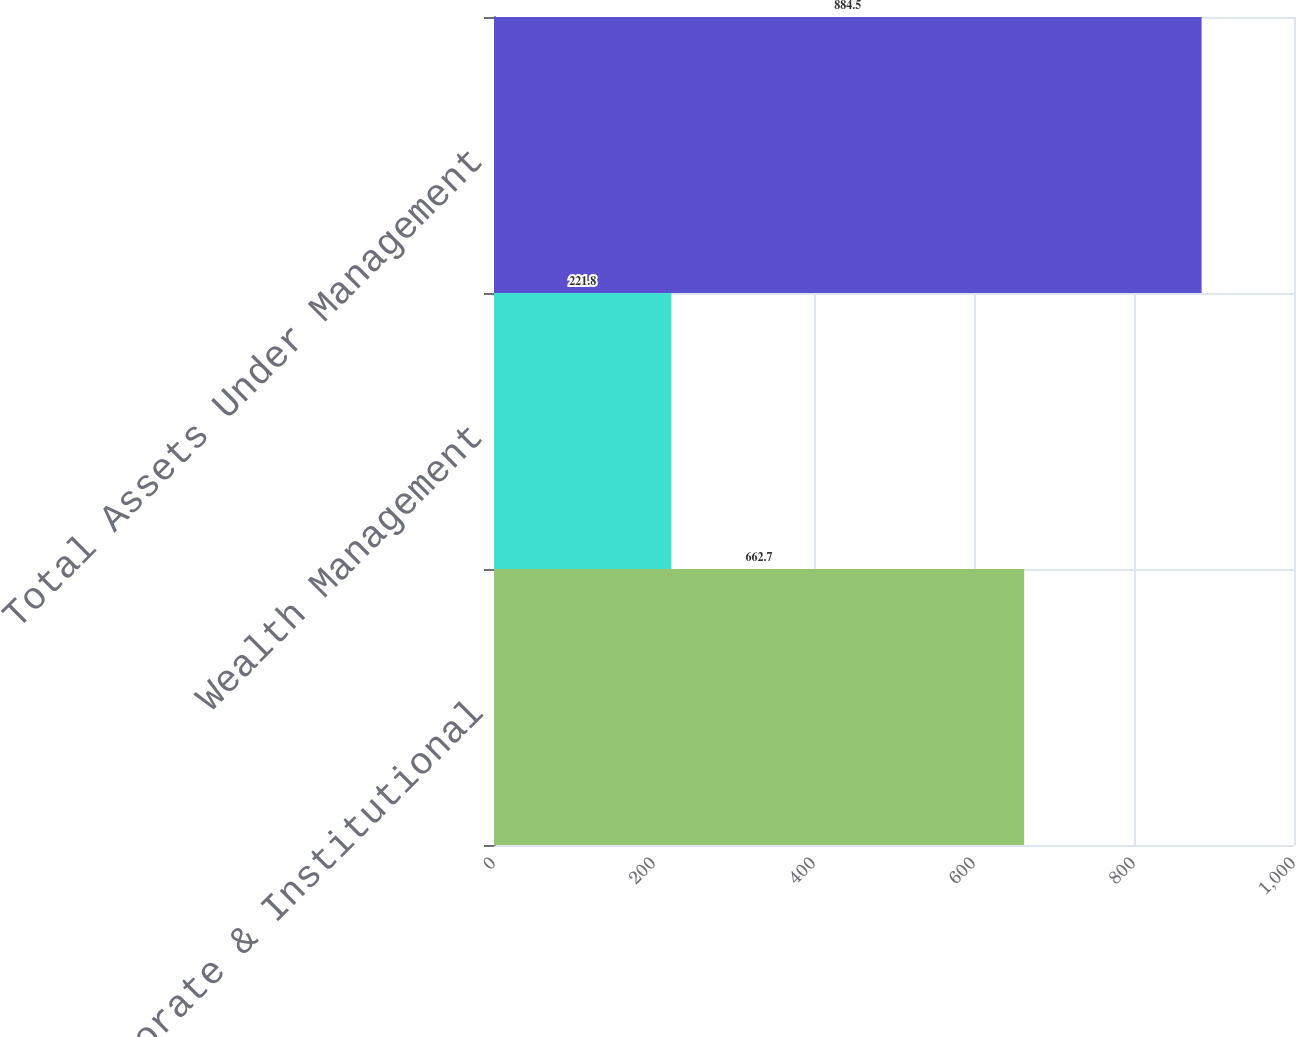Convert chart to OTSL. <chart><loc_0><loc_0><loc_500><loc_500><bar_chart><fcel>Corporate & Institutional<fcel>Wealth Management<fcel>Total Assets Under Management<nl><fcel>662.7<fcel>221.8<fcel>884.5<nl></chart> 